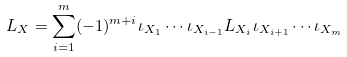<formula> <loc_0><loc_0><loc_500><loc_500>L _ { X } = \sum _ { i = 1 } ^ { m } ( - 1 ) ^ { m + i } \iota _ { X _ { 1 } } \cdots \iota _ { X _ { i - 1 } } L _ { X _ { i } } \iota _ { X _ { i + 1 } } \cdots \iota _ { X _ { m } }</formula> 